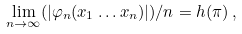<formula> <loc_0><loc_0><loc_500><loc_500>\lim _ { n \rightarrow \infty } ( | \varphi _ { n } ( x _ { 1 } \dots x _ { n } ) | ) / n = h ( \pi ) \, ,</formula> 